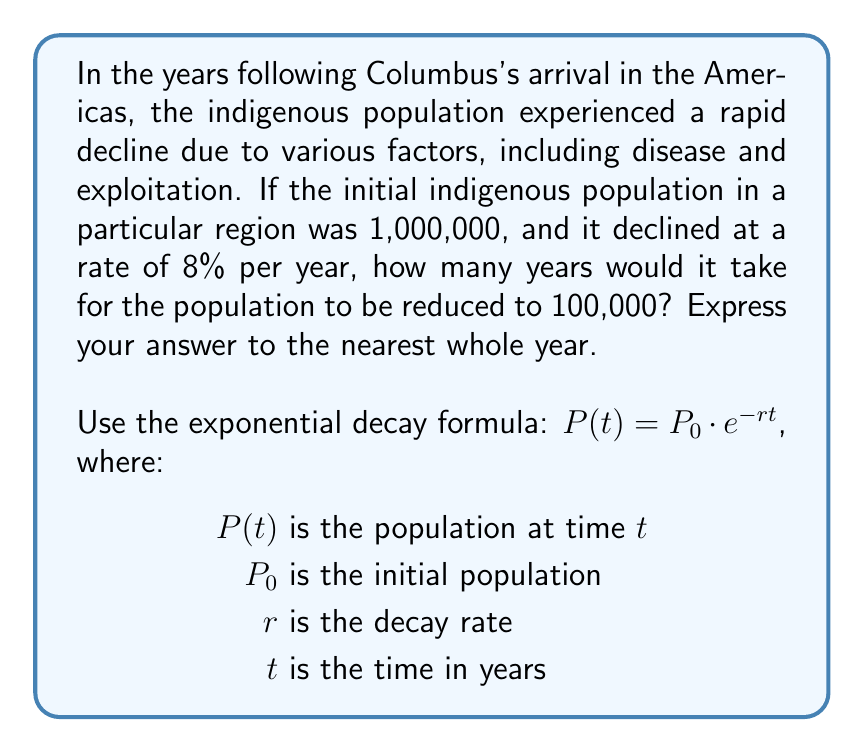Solve this math problem. Let's approach this step-by-step:

1) We're given:
   $P_0 = 1,000,000$ (initial population)
   $r = 0.08$ (8% annual decay rate)
   $P(t) = 100,000$ (final population)

2) We need to solve for $t$ in the equation:
   $100,000 = 1,000,000 * e^{-0.08t}$

3) Divide both sides by 1,000,000:
   $0.1 = e^{-0.08t}$

4) Take the natural log of both sides:
   $\ln(0.1) = -0.08t$

5) Solve for $t$:
   $t = \frac{\ln(0.1)}{-0.08}$

6) Calculate:
   $t = \frac{-2.30258509...}{-0.08} \approx 28.78231368...$

7) Rounding to the nearest whole year:
   $t \approx 29$ years
Answer: It would take approximately 29 years for the indigenous population to be reduced from 1,000,000 to 100,000 at an 8% annual decay rate. 